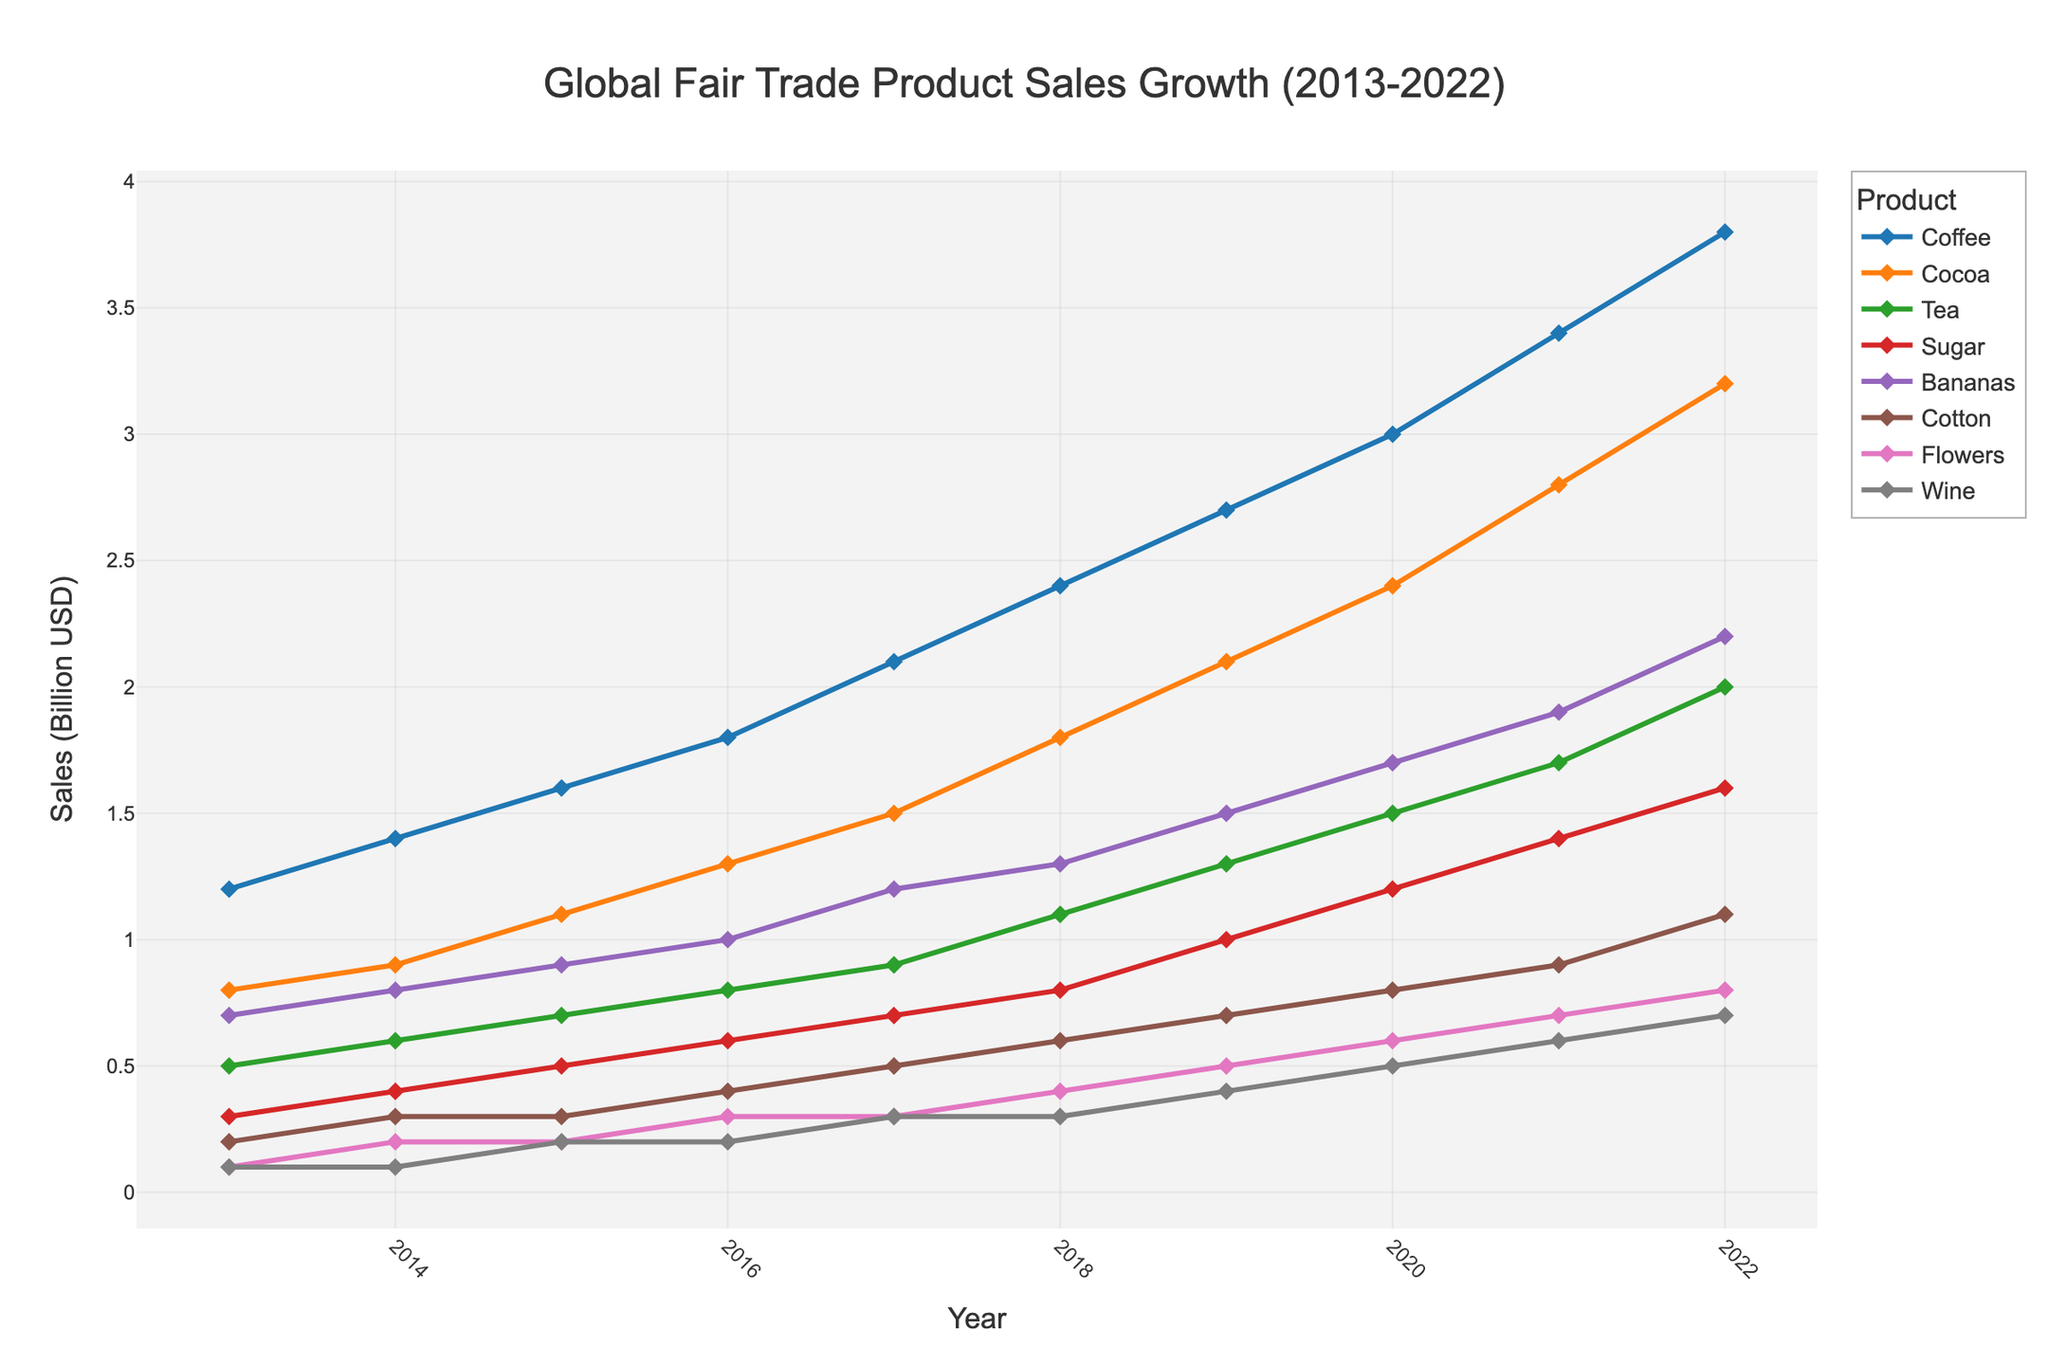What's the overall trend in global fair trade product sales for coffee from 2013 to 2022? Coffee sales show a consistent upward trend from 1.2 billion USD in 2013 to 3.8 billion USD in 2022.
Answer: Upward trend Which year had the highest sales for fair trade bananas, and how much was sold? The highest sales for fair trade bananas were in 2022, with a total of 2.2 billion USD sold.
Answer: 2022, 2.2 billion USD Comparing coffee and cocoa sales in 2017, which had higher sales and by how much? In 2017, coffee sales were at 2.1 billion USD and cocoa sales were at 1.5 billion USD, making coffee sales higher by 0.6 billion USD.
Answer: Coffee by 0.6 billion USD By how much did tea sales increase from 2015 to 2022? Tea sales increased from 0.7 billion USD in 2015 to 2.0 billion USD in 2022, resulting in an increase of 1.3 billion USD.
Answer: 1.3 billion USD Among the products shown, which had the lowest sales in 2013 and what was the amount? In 2013, flowers and wine both had the lowest sales at 0.1 billion USD.
Answer: Flowers and wine, 0.1 billion USD What's the average sales of fair trade cotton from 2013 to 2022? The sales figures for cotton from 2013 to 2022 are 0.2, 0.3, 0.3, 0.4, 0.5, 0.6, 0.7, 0.8, 0.9, and 1.1 billion USD respectively. Sum these values to get 5.8 billion USD and divide by 10 to find the average: 5.8 / 10 = 0.58 billion USD.
Answer: 0.58 billion USD What is the total sales growth for sugar from 2013 to 2022? Sugar sales increased from 0.3 billion USD in 2013 to 1.6 billion USD in 2022. The sales growth is: 1.6 - 0.3 = 1.3 billion USD.
Answer: 1.3 billion USD During which year did fair trade flowers' sales first reach or exceed 0.5 billion USD? The sales of fair trade flowers first reached 0.5 billion USD in 2019 at 0.5 billion USD.
Answer: 2019 